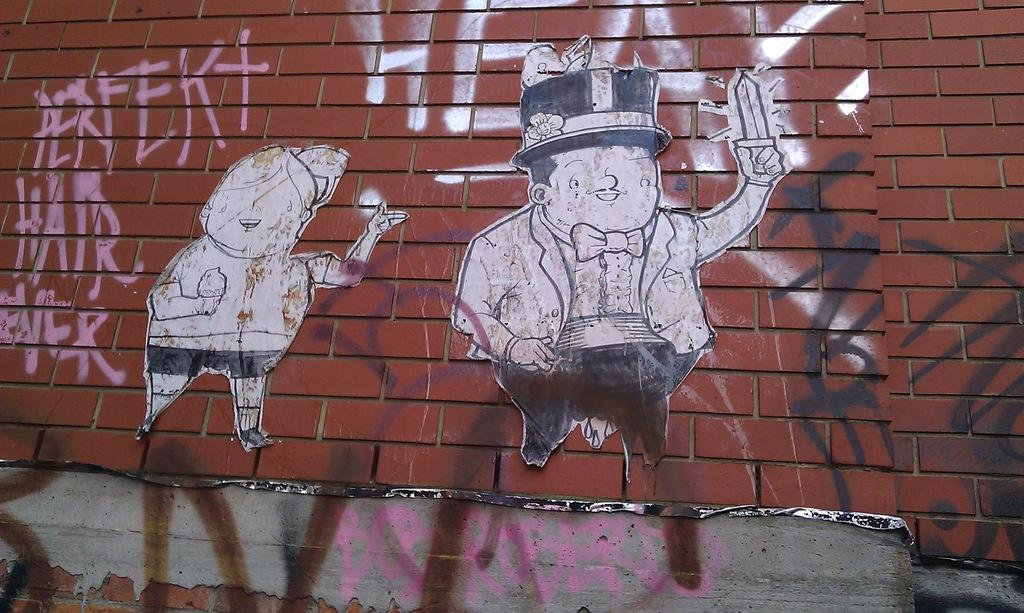What type of structure is visible in the image in the image? There is a brick wall in the image. What is on the brick wall? There are posters and graffiti on the wall. How many cars are parked in front of the brick wall in the image? There is no information about cars in the image, as it only shows a brick wall with posters and graffiti. 